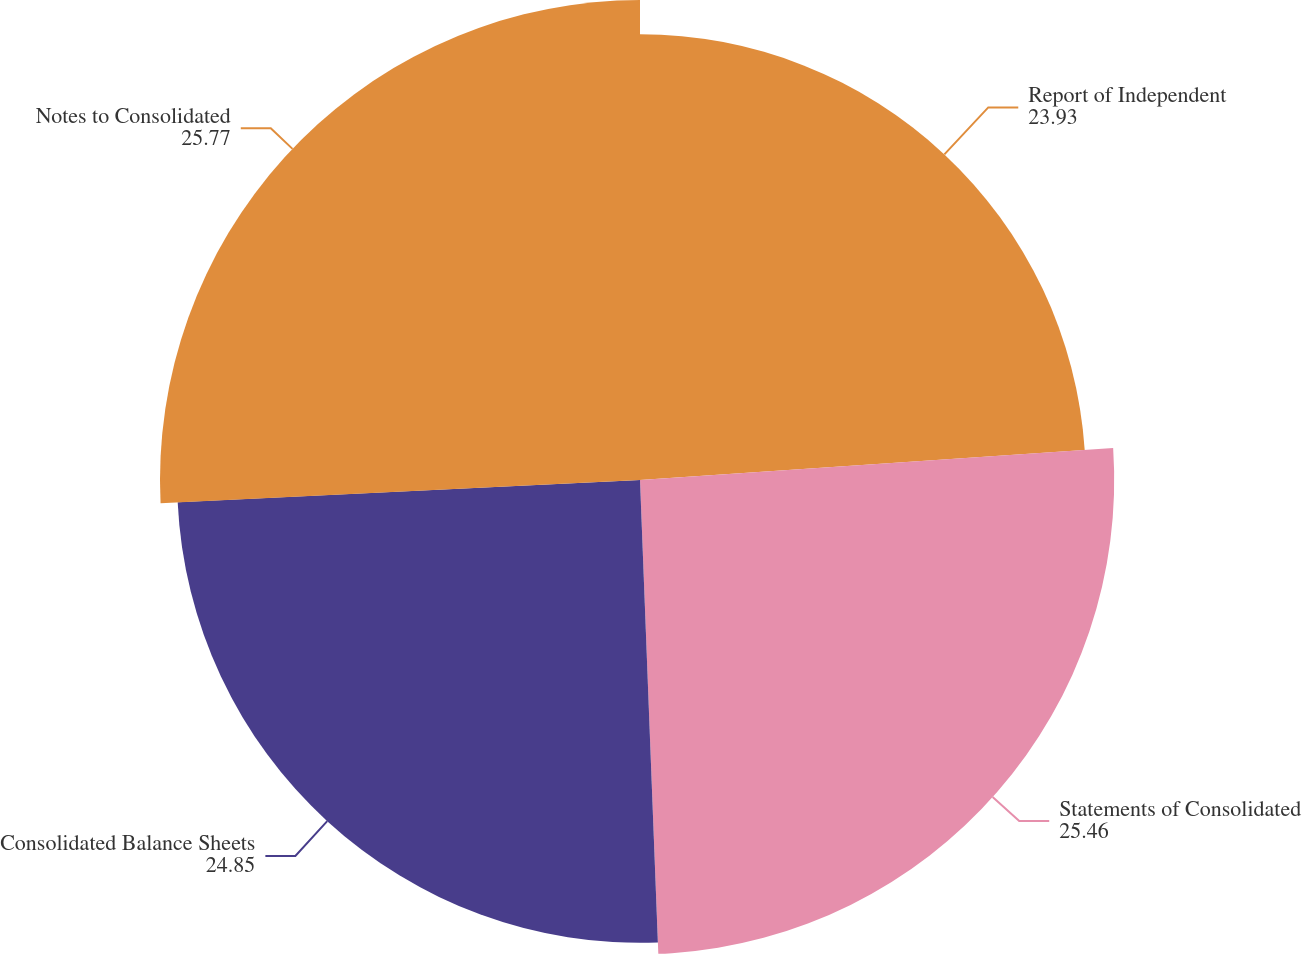<chart> <loc_0><loc_0><loc_500><loc_500><pie_chart><fcel>Report of Independent<fcel>Statements of Consolidated<fcel>Consolidated Balance Sheets<fcel>Notes to Consolidated<nl><fcel>23.93%<fcel>25.46%<fcel>24.85%<fcel>25.77%<nl></chart> 